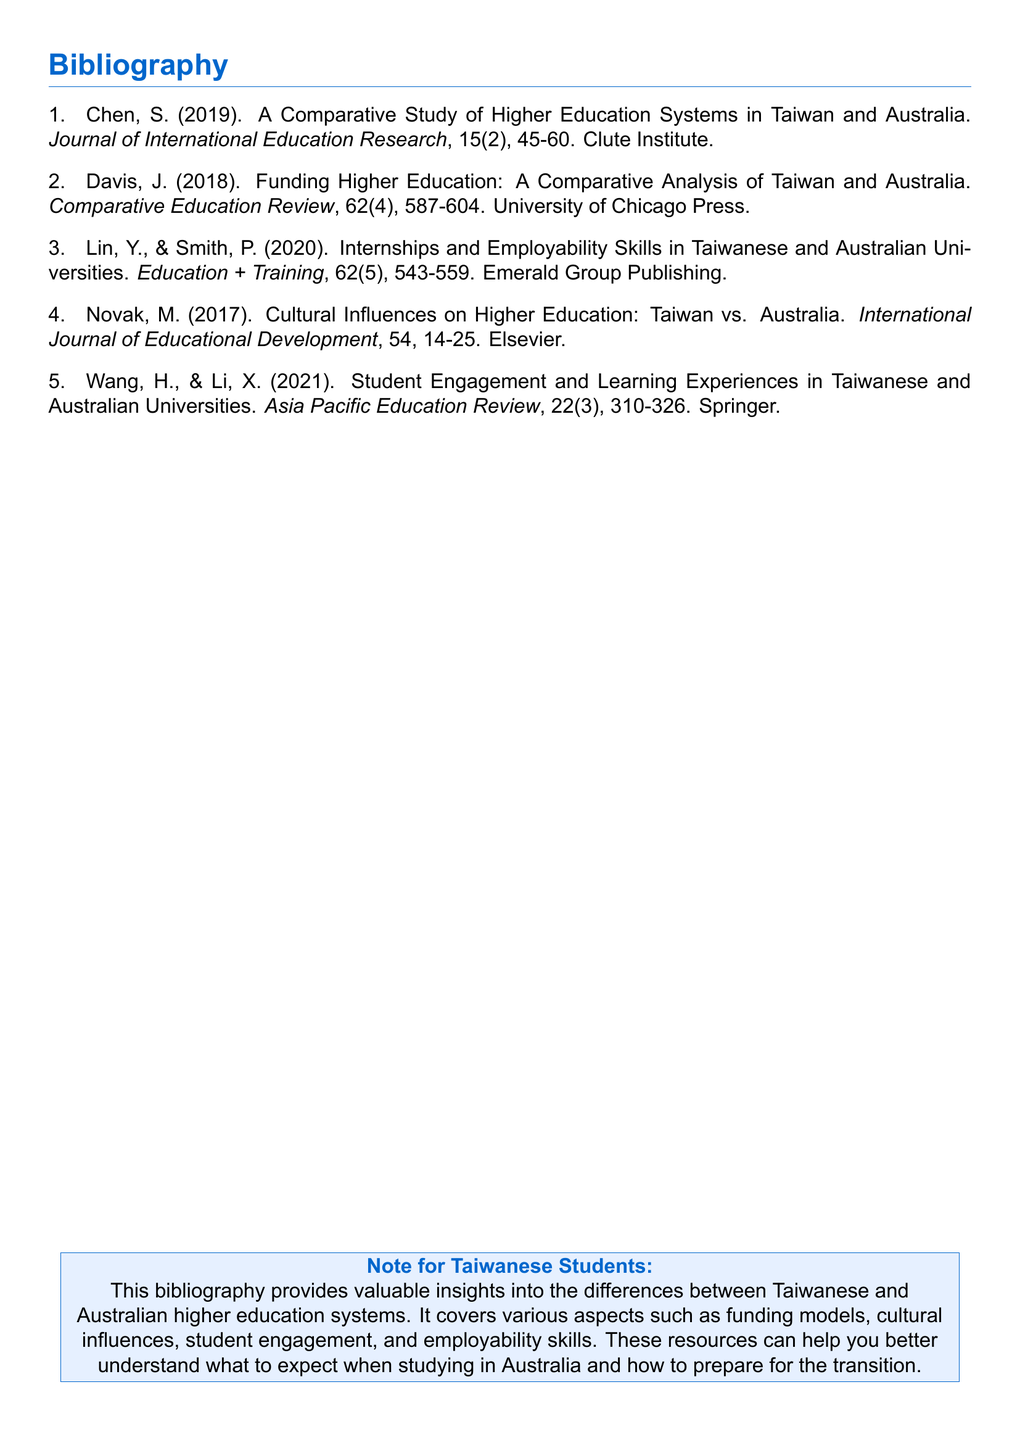what is the first author's name in the bibliography? The first author's name listed is Chen, S.
Answer: Chen, S how many articles are authored by Wang and Li? Wang, H. and Li, X. co-author one article in the document.
Answer: 1 which journal published the article on cultural influences? The article on cultural influences is published in the International Journal of Educational Development.
Answer: International Journal of Educational Development what year was the article on employability skills published? The article on internships and employability skills was published in 2020.
Answer: 2020 who are the authors of the article discussing funding higher education? The authors of the funding article are Davis, J.
Answer: Davis, J how many articles are referenced in total? The bibliography contains a total of five articles.
Answer: 5 which publisher released the article by Novak? The article by Novak was published by Elsevier.
Answer: Elsevier what is the main theme covered in this bibliography? The bibliography focuses on the differences between Taiwanese and Australian higher education systems.
Answer: Differences between Taiwanese and Australian higher education systems what is the title of the last article listed? The title of the last article is "Student Engagement and Learning Experiences in Taiwanese and Australian Universities."
Answer: Student Engagement and Learning Experiences in Taiwanese and Australian Universities 